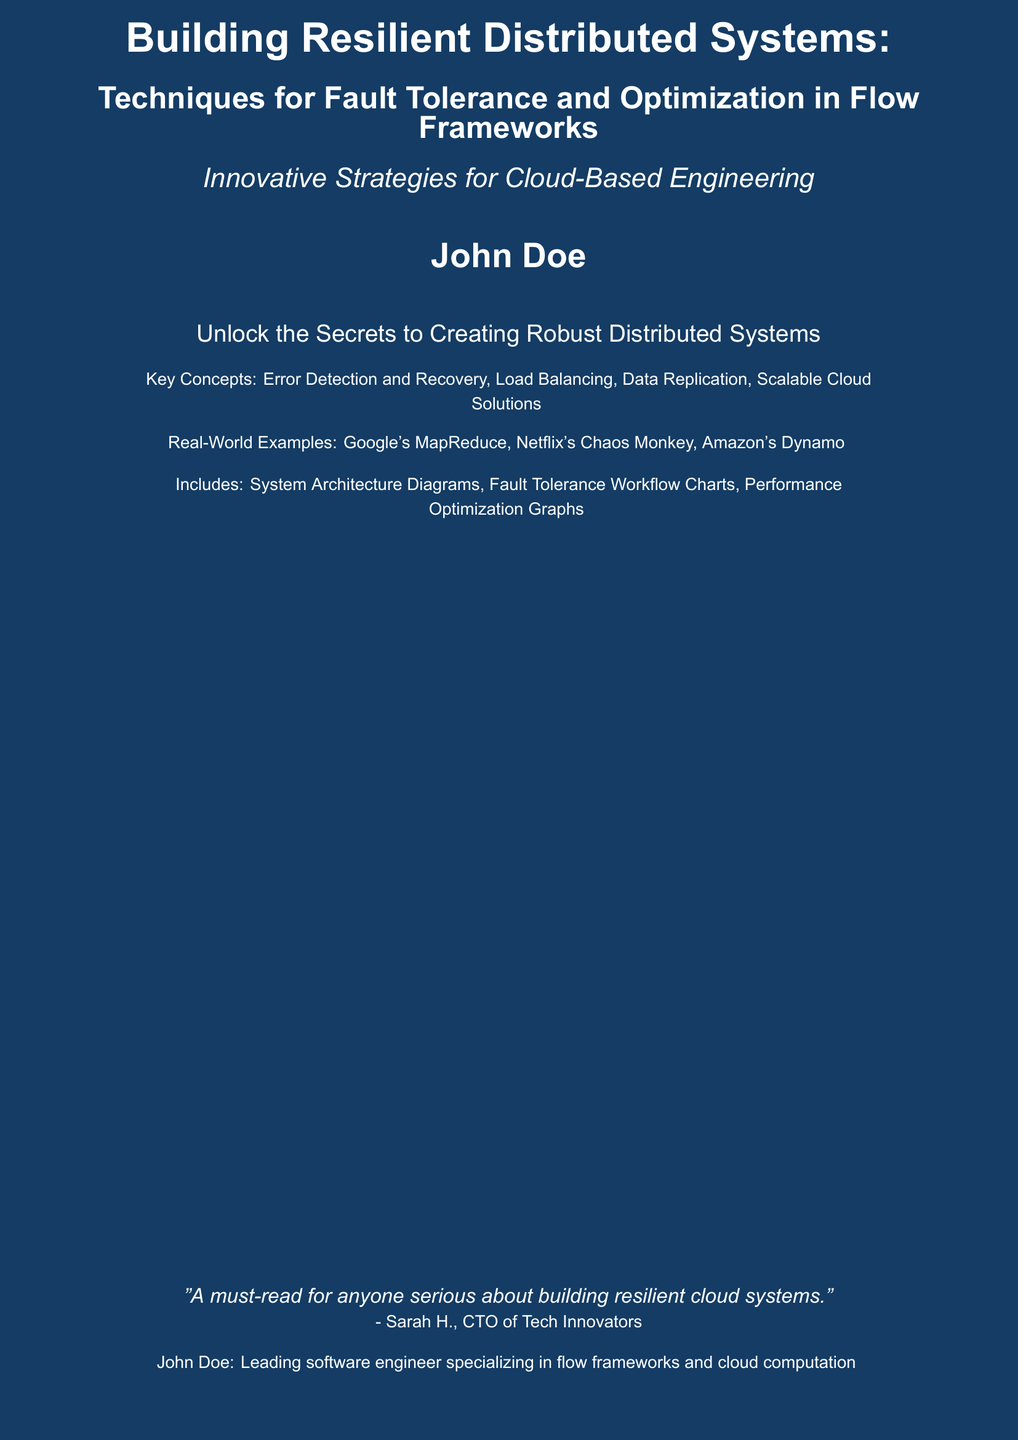What is the title of the book? The title of the book is everything in the first line of the cover.
Answer: Building Resilient Distributed Systems Who is the author of the book? The author is indicated below the book title on the cover.
Answer: John Doe What key concepts are highlighted in the book? The key concepts are listed in the small text section on the cover.
Answer: Error Detection and Recovery, Load Balancing, Data Replication, Scalable Cloud Solutions Which companies are mentioned as real-world examples? The real-world examples are detailed in the text on the cover.
Answer: Google's MapReduce, Netflix's Chaos Monkey, Amazon's Dynamo What is the main theme of the book? The main theme is encapsulated in the subtitle below the title.
Answer: Techniques for Fault Tolerance and Optimization in Flow Frameworks What type of graphs and charts does the book include? The types of graphs and charts are outlined in the section about the content of the book.
Answer: System Architecture Diagrams, Fault Tolerance Workflow Charts, Performance Optimization Graphs What is the quote on the cover? The quote is attributed to a person and provides insight on the book's value.
Answer: "A must-read for anyone serious about building resilient cloud systems." What is the professional background of the author? The author's background is stated in a small text section at the bottom.
Answer: Leading software engineer specializing in flow frameworks and cloud computation 